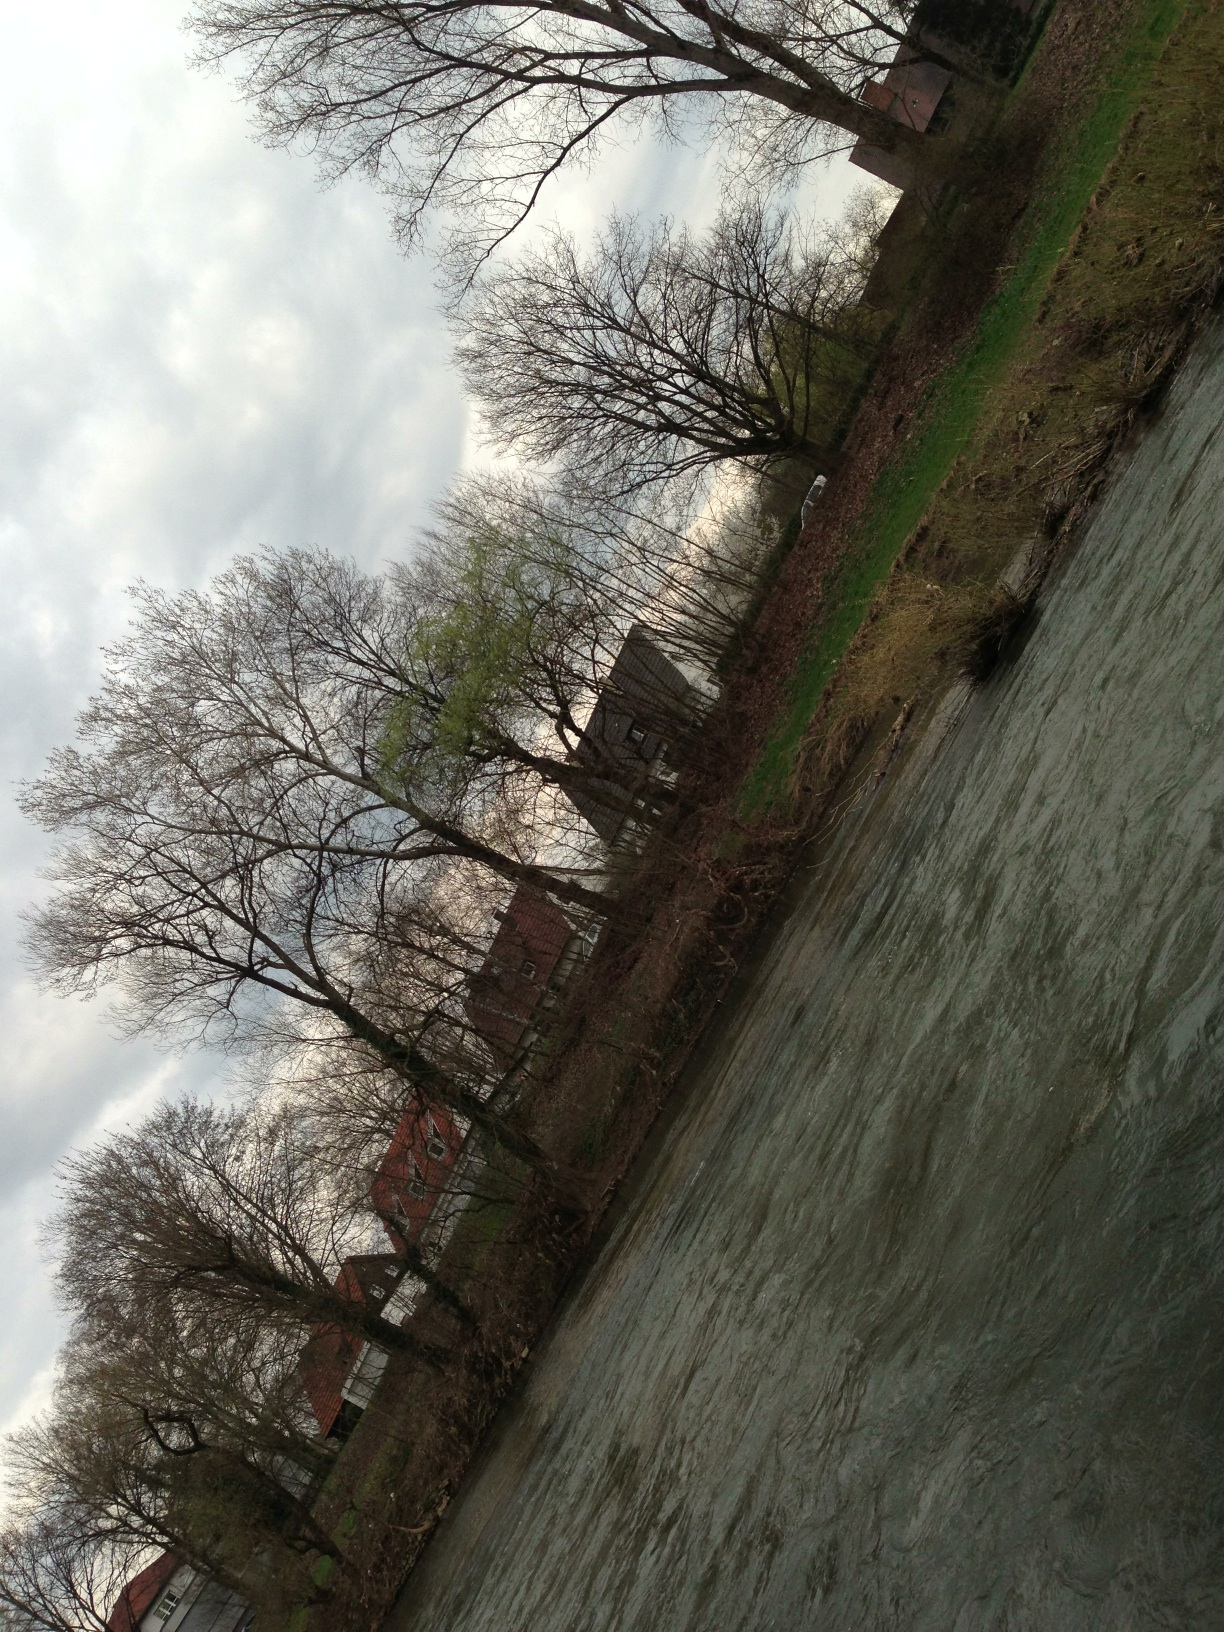What features in this landscape indicate the season? The leafless trees and overcast sky suggest it might be late winter or early spring, when foliage has not yet fully emerged. 